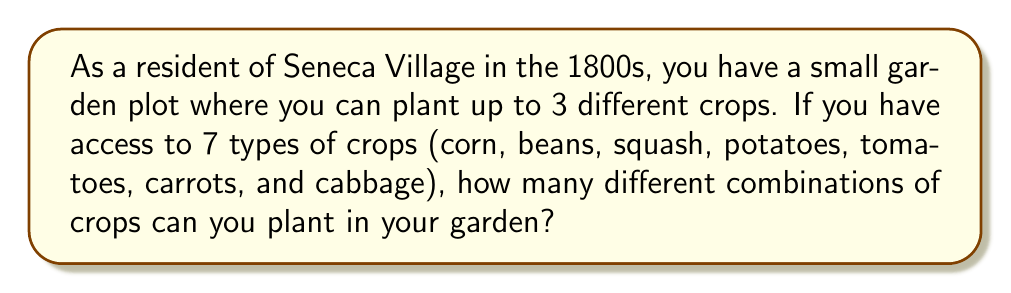Provide a solution to this math problem. Let's approach this step-by-step using combinatorics:

1) We are selecting 0 to 3 crops from a total of 7 available crops. This is a combination problem with varying selection sizes.

2) We need to calculate the sum of combinations for selecting 0, 1, 2, and 3 crops:

   $${7 \choose 0} + {7 \choose 1} + {7 \choose 2} + {7 \choose 3}$$

3) Let's calculate each combination:

   a) ${7 \choose 0} = 1$ (There's only one way to choose nothing)
   
   b) ${7 \choose 1} = 7$ (There are 7 ways to choose 1 crop)
   
   c) ${7 \choose 2} = \frac{7!}{2!(7-2)!} = \frac{7 \cdot 6}{2 \cdot 1} = 21$
   
   d) ${7 \choose 3} = \frac{7!}{3!(7-3)!} = \frac{7 \cdot 6 \cdot 5}{3 \cdot 2 \cdot 1} = 35$

4) Now, we sum these values:

   $$1 + 7 + 21 + 35 = 64$$

Therefore, there are 64 different combinations of crops that can be planted in the garden.
Answer: 64 combinations 